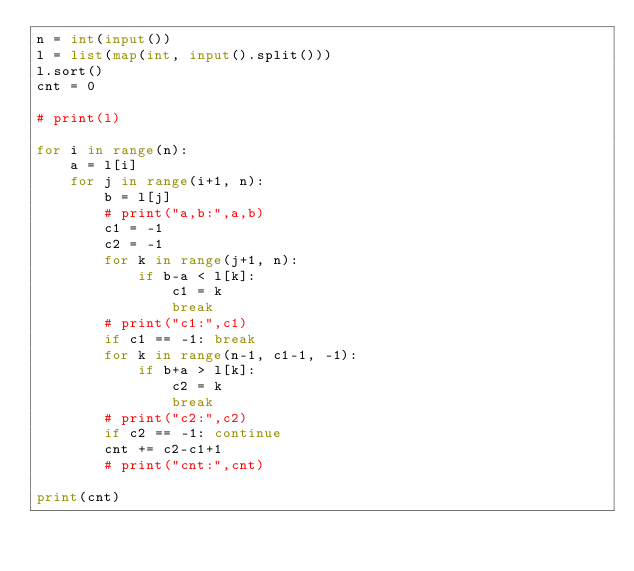<code> <loc_0><loc_0><loc_500><loc_500><_Python_>n = int(input())
l = list(map(int, input().split()))
l.sort()
cnt = 0

# print(l)

for i in range(n):
	a = l[i]
	for j in range(i+1, n):
		b = l[j]
		# print("a,b:",a,b)
		c1 = -1
		c2 = -1
		for k in range(j+1, n):
			if b-a < l[k]:
				c1 = k
				break
		# print("c1:",c1)
		if c1 == -1: break
		for k in range(n-1, c1-1, -1):
			if b+a > l[k]:
				c2 = k
				break
		# print("c2:",c2)
		if c2 == -1: continue
		cnt += c2-c1+1
		# print("cnt:",cnt)

print(cnt)
</code> 